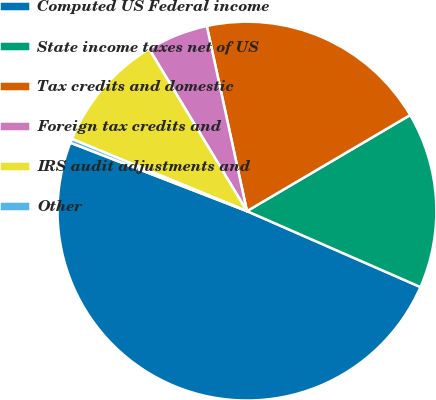Convert chart to OTSL. <chart><loc_0><loc_0><loc_500><loc_500><pie_chart><fcel>Computed US Federal income<fcel>State income taxes net of US<fcel>Tax credits and domestic<fcel>Foreign tax credits and<fcel>IRS audit adjustments and<fcel>Other<nl><fcel>49.31%<fcel>15.03%<fcel>19.93%<fcel>5.24%<fcel>10.14%<fcel>0.34%<nl></chart> 